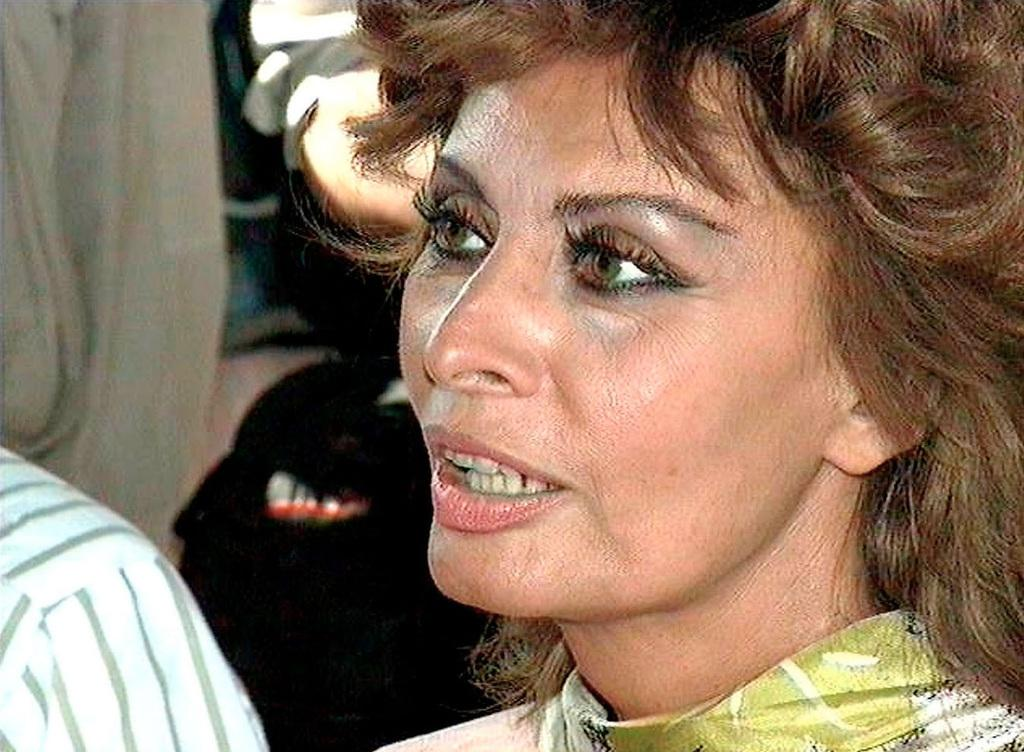What is the primary subject of the image? There is a woman in the image. Can you describe any other people present in the image? The facts only mention that there may be other people present beside the woman, so we cannot provide specific details about them. What type of goat can be seen in the wilderness in the image? There is no goat or wilderness present in the image; it features a woman. 